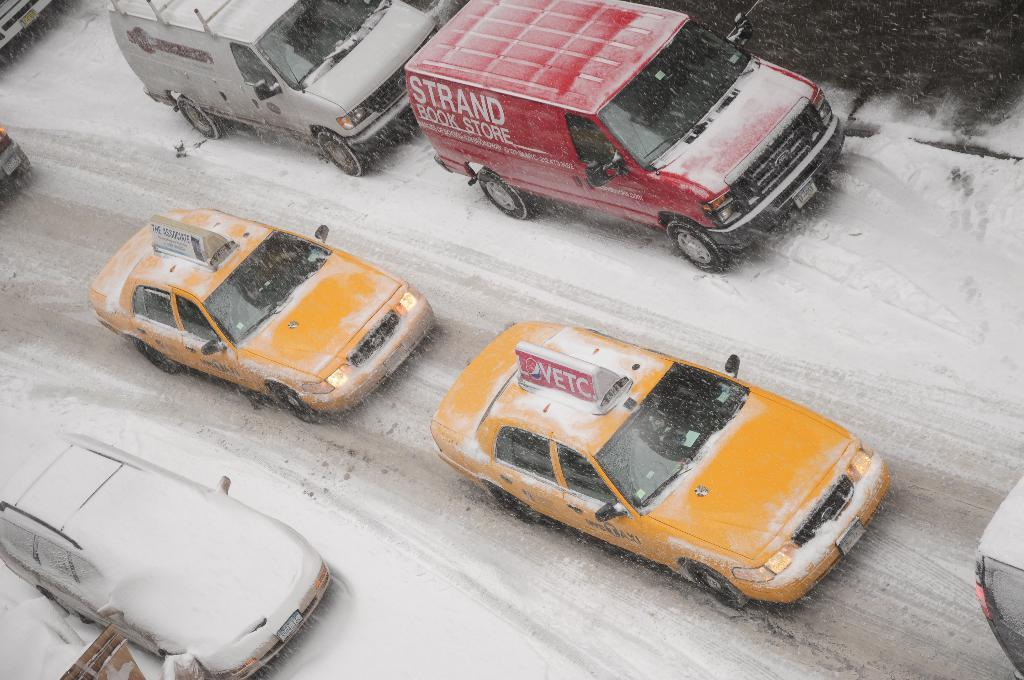<image>
Render a clear and concise summary of the photo. An snow covered street with taxis one of which is advertising VETC. 